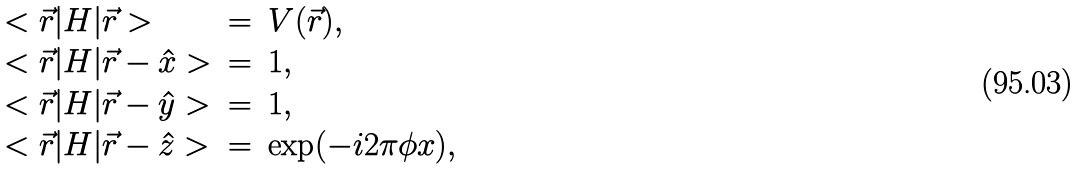Convert formula to latex. <formula><loc_0><loc_0><loc_500><loc_500>\begin{array} { l l l } < \vec { r } | H | \vec { r } > & = & V ( \vec { r } ) , \\ < \vec { r } | H | \vec { r } - \hat { x } > & = & 1 , \\ < \vec { r } | H | \vec { r } - \hat { y } > & = & 1 , \\ < \vec { r } | H | \vec { r } - \hat { z } > & = & \exp ( - i 2 \pi \phi x ) , \end{array}</formula> 